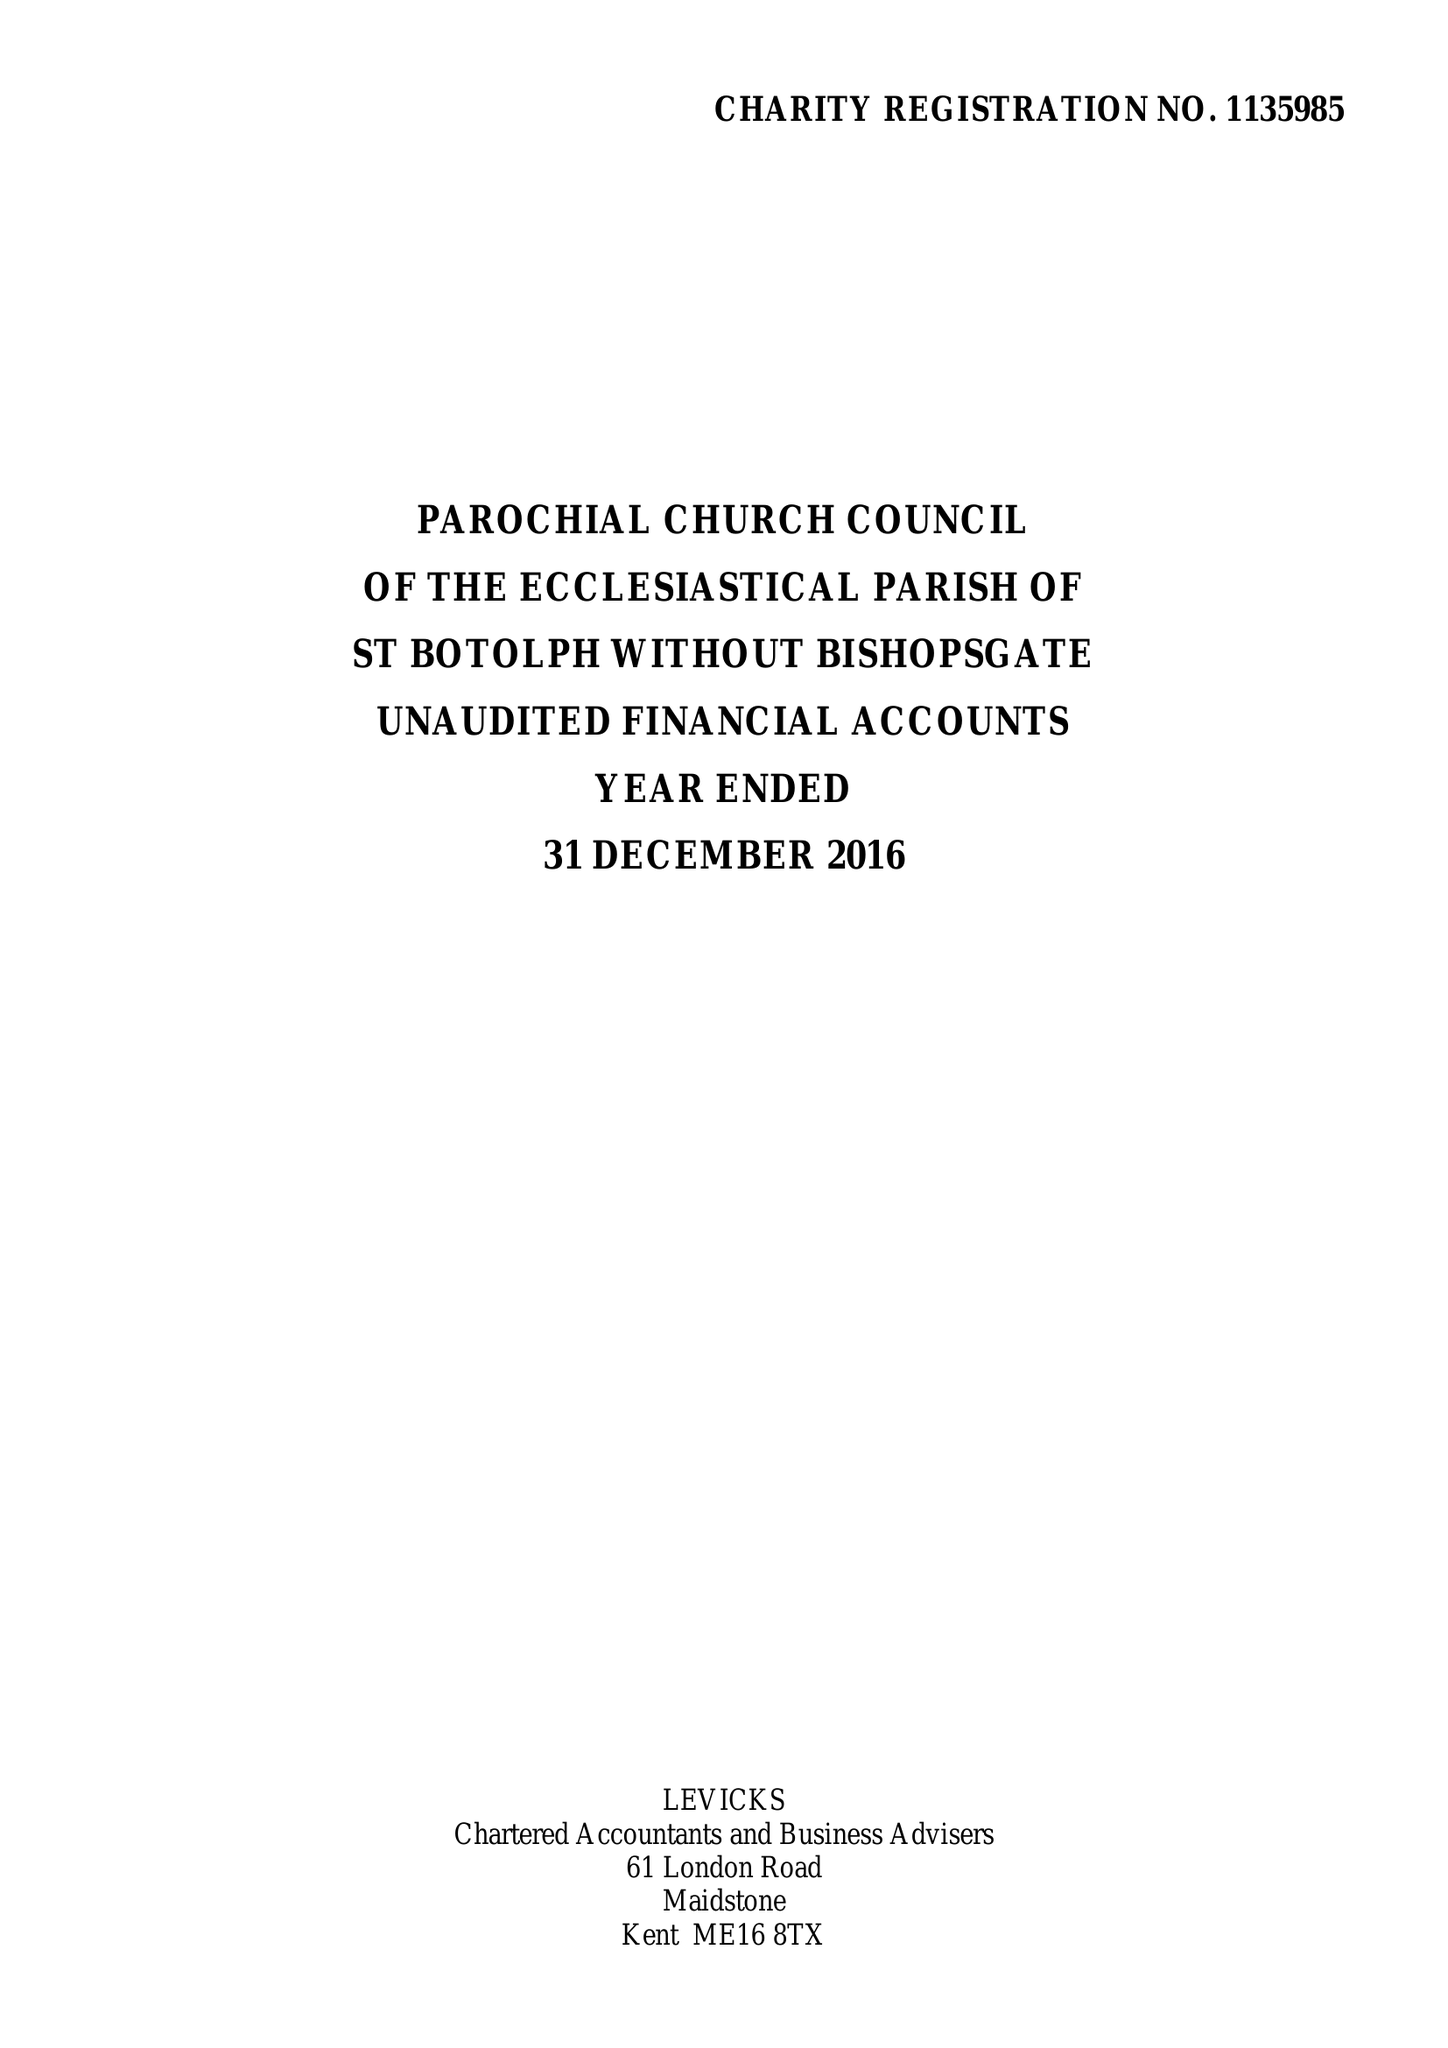What is the value for the spending_annually_in_british_pounds?
Answer the question using a single word or phrase. 278005.00 